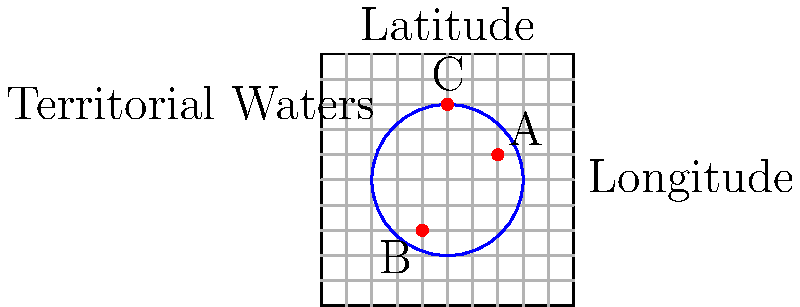A circular territorial water boundary with a radius of 3 units is centered at (0,0). Three vessels are detected at coordinates A(2,1), B(-1,-2), and C(0,3). Which vessel(s) is/are within the territorial waters? To determine which vessels are within territorial waters, we need to calculate the distance of each vessel from the origin (0,0) and compare it to the radius of the territorial waters (3 units).

1. For vessel A at (2,1):
   Distance = $\sqrt{2^2 + 1^2} = \sqrt{5} \approx 2.24$
   2.24 < 3, so vessel A is within territorial waters.

2. For vessel B at (-1,-2):
   Distance = $\sqrt{(-1)^2 + (-2)^2} = \sqrt{5} \approx 2.24$
   2.24 < 3, so vessel B is within territorial waters.

3. For vessel C at (0,3):
   Distance = $\sqrt{0^2 + 3^2} = 3$
   3 = 3, so vessel C is exactly on the boundary of territorial waters.

In maritime law, vessels on the boundary are typically considered within territorial waters.
Answer: Vessels A, B, and C 